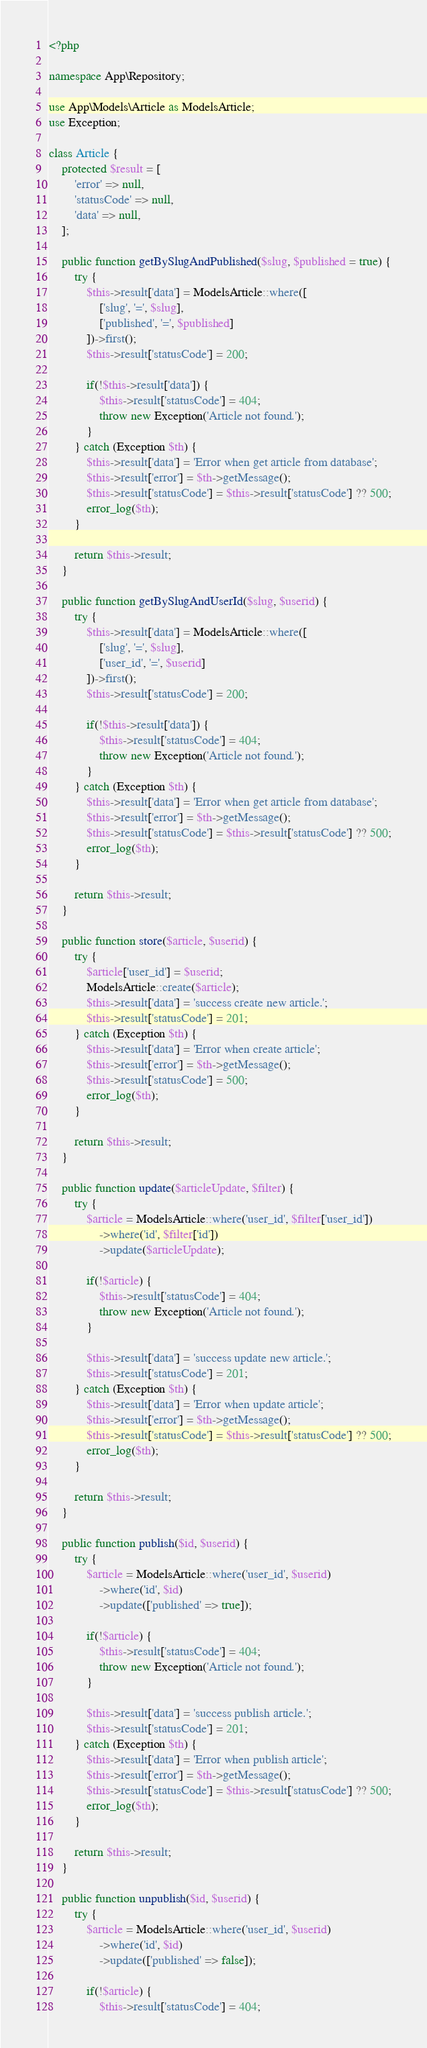<code> <loc_0><loc_0><loc_500><loc_500><_PHP_><?php

namespace App\Repository;

use App\Models\Article as ModelsArticle;
use Exception;

class Article {
    protected $result = [
        'error' => null,
        'statusCode' => null,
        'data' => null,
    ];

    public function getBySlugAndPublished($slug, $published = true) {
        try {
            $this->result['data'] = ModelsArticle::where([
                ['slug', '=', $slug],
                ['published', '=', $published]
            ])->first();
            $this->result['statusCode'] = 200;

            if(!$this->result['data']) {
                $this->result['statusCode'] = 404;
                throw new Exception('Article not found.');
            }
        } catch (Exception $th) {
            $this->result['data'] = 'Error when get article from database';
            $this->result['error'] = $th->getMessage();
            $this->result['statusCode'] = $this->result['statusCode'] ?? 500;
            error_log($th);
        }

        return $this->result;
    }

    public function getBySlugAndUserId($slug, $userid) {
        try {
            $this->result['data'] = ModelsArticle::where([
                ['slug', '=', $slug],
                ['user_id', '=', $userid]
            ])->first();
            $this->result['statusCode'] = 200;

            if(!$this->result['data']) {
                $this->result['statusCode'] = 404;
                throw new Exception('Article not found.');
            }
        } catch (Exception $th) {
            $this->result['data'] = 'Error when get article from database';
            $this->result['error'] = $th->getMessage();
            $this->result['statusCode'] = $this->result['statusCode'] ?? 500;
            error_log($th);
        }

        return $this->result;
    }

    public function store($article, $userid) {
        try {
            $article['user_id'] = $userid;
            ModelsArticle::create($article);
            $this->result['data'] = 'success create new article.';
            $this->result['statusCode'] = 201;
        } catch (Exception $th) {
            $this->result['data'] = 'Error when create article';
            $this->result['error'] = $th->getMessage();
            $this->result['statusCode'] = 500;
            error_log($th);
        }

        return $this->result;
    }

    public function update($articleUpdate, $filter) {
        try {
            $article = ModelsArticle::where('user_id', $filter['user_id'])
                ->where('id', $filter['id'])
                ->update($articleUpdate);

            if(!$article) {
                $this->result['statusCode'] = 404;
                throw new Exception('Article not found.');
            }

            $this->result['data'] = 'success update new article.';
            $this->result['statusCode'] = 201;
        } catch (Exception $th) {
            $this->result['data'] = 'Error when update article';
            $this->result['error'] = $th->getMessage();
            $this->result['statusCode'] = $this->result['statusCode'] ?? 500;
            error_log($th);
        }

        return $this->result;
    }

    public function publish($id, $userid) {
        try {
            $article = ModelsArticle::where('user_id', $userid)
                ->where('id', $id)
                ->update(['published' => true]);

            if(!$article) {
                $this->result['statusCode'] = 404;
                throw new Exception('Article not found.');
            }
            
            $this->result['data'] = 'success publish article.';
            $this->result['statusCode'] = 201;
        } catch (Exception $th) {
            $this->result['data'] = 'Error when publish article';
            $this->result['error'] = $th->getMessage();
            $this->result['statusCode'] = $this->result['statusCode'] ?? 500;
            error_log($th);
        }

        return $this->result;
    }

    public function unpublish($id, $userid) {
        try {
            $article = ModelsArticle::where('user_id', $userid)
                ->where('id', $id)
                ->update(['published' => false]);

            if(!$article) {
                $this->result['statusCode'] = 404;</code> 